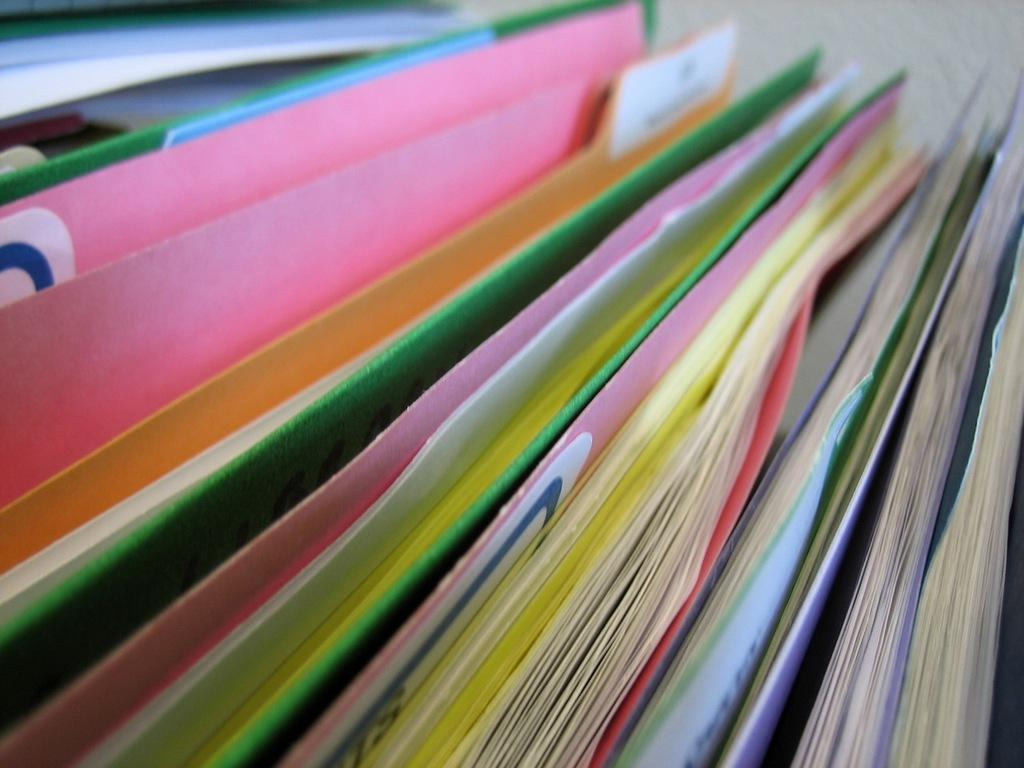What is the primary subject of the image? The primary subject of the image is a row of books. How are the books arranged in the image? The books are arranged in a row. Can you describe the number of books in the image? The image shows many books arranged in a row. What type of ball is being used to draw attention to the insurance policy in the image? There is no ball or insurance policy present in the image; it only features a row of books. 